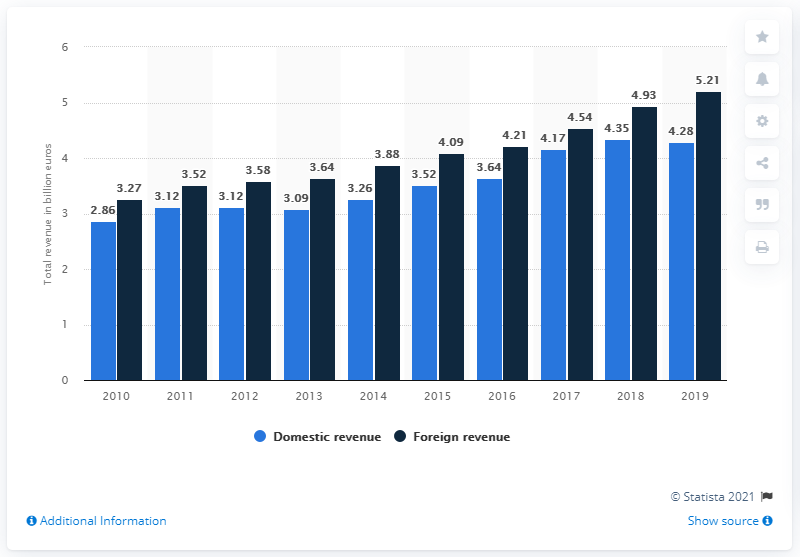Give some essential details in this illustration. The domestic revenue generated by the German industry for analysis, bio, and laboratory technologies in 2019 was 4.28 billion euros. In 2019, there was a significant difference in revenue between two different years. The foreign revenue of the German industry for analysis, bio, and laboratory technologies in 2019 was 5.21 billion euros. In 2019, foreign revenue reached its peak. 